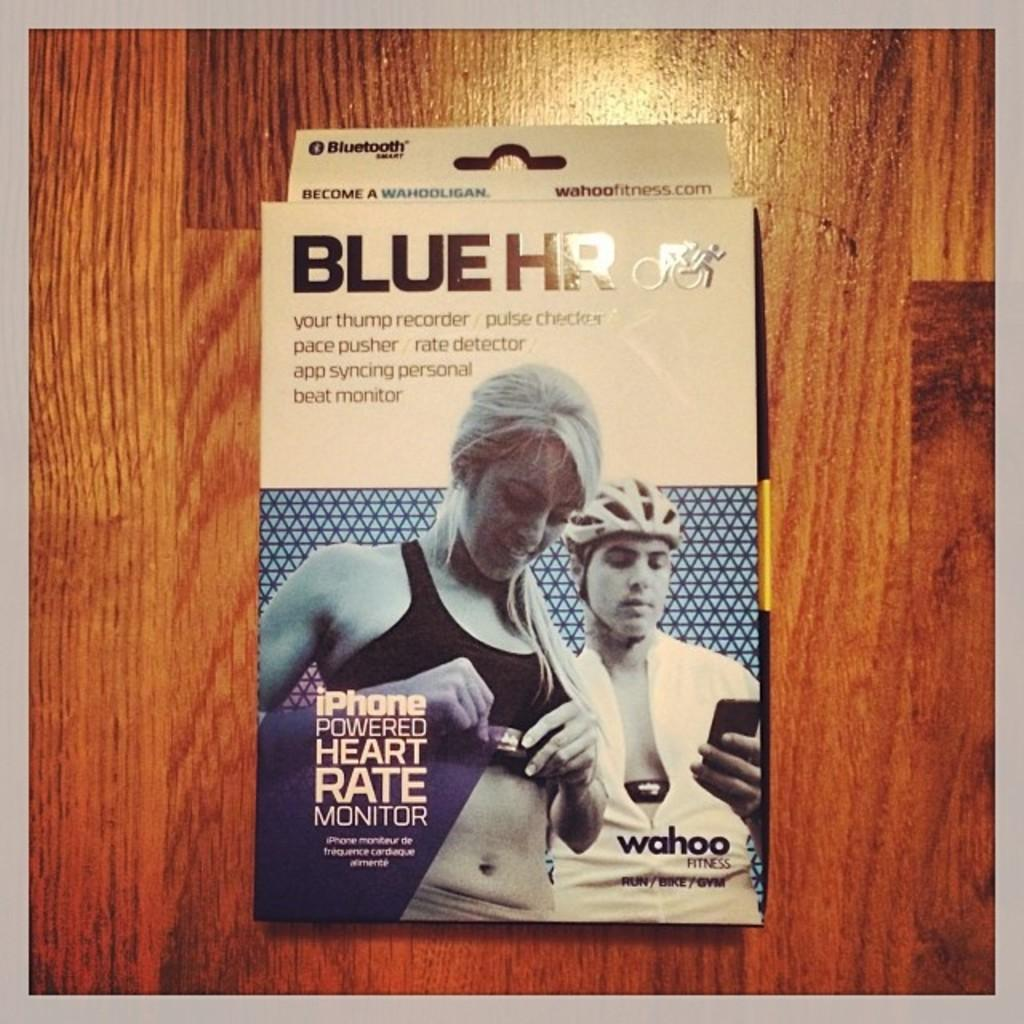<image>
Render a clear and concise summary of the photo. An iPhone powered heart rate monitor from the brand Blue HR. 